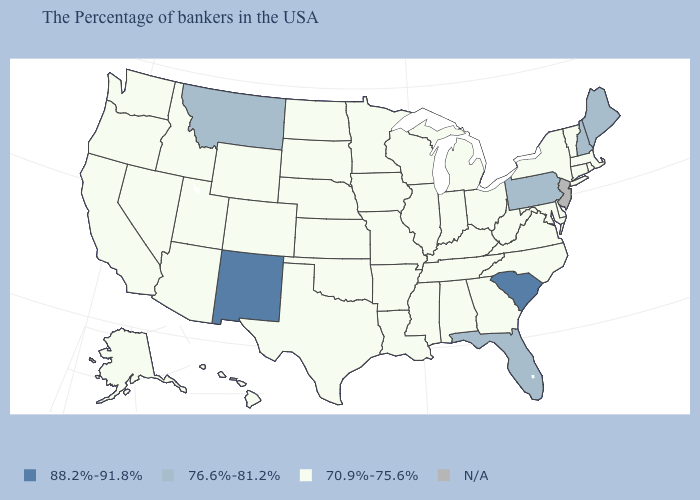Name the states that have a value in the range 76.6%-81.2%?
Write a very short answer. Maine, New Hampshire, Pennsylvania, Florida, Montana. What is the value of Alabama?
Keep it brief. 70.9%-75.6%. What is the value of West Virginia?
Concise answer only. 70.9%-75.6%. What is the value of New York?
Quick response, please. 70.9%-75.6%. What is the highest value in the USA?
Short answer required. 88.2%-91.8%. Which states hav the highest value in the West?
Give a very brief answer. New Mexico. What is the value of Indiana?
Short answer required. 70.9%-75.6%. Does South Carolina have the highest value in the South?
Short answer required. Yes. Among the states that border Wyoming , which have the lowest value?
Write a very short answer. Nebraska, South Dakota, Colorado, Utah, Idaho. Does the first symbol in the legend represent the smallest category?
Quick response, please. No. Name the states that have a value in the range 70.9%-75.6%?
Be succinct. Massachusetts, Rhode Island, Vermont, Connecticut, New York, Delaware, Maryland, Virginia, North Carolina, West Virginia, Ohio, Georgia, Michigan, Kentucky, Indiana, Alabama, Tennessee, Wisconsin, Illinois, Mississippi, Louisiana, Missouri, Arkansas, Minnesota, Iowa, Kansas, Nebraska, Oklahoma, Texas, South Dakota, North Dakota, Wyoming, Colorado, Utah, Arizona, Idaho, Nevada, California, Washington, Oregon, Alaska, Hawaii. What is the highest value in states that border Michigan?
Give a very brief answer. 70.9%-75.6%. Which states hav the highest value in the Northeast?
Be succinct. Maine, New Hampshire, Pennsylvania. What is the lowest value in the USA?
Answer briefly. 70.9%-75.6%. 